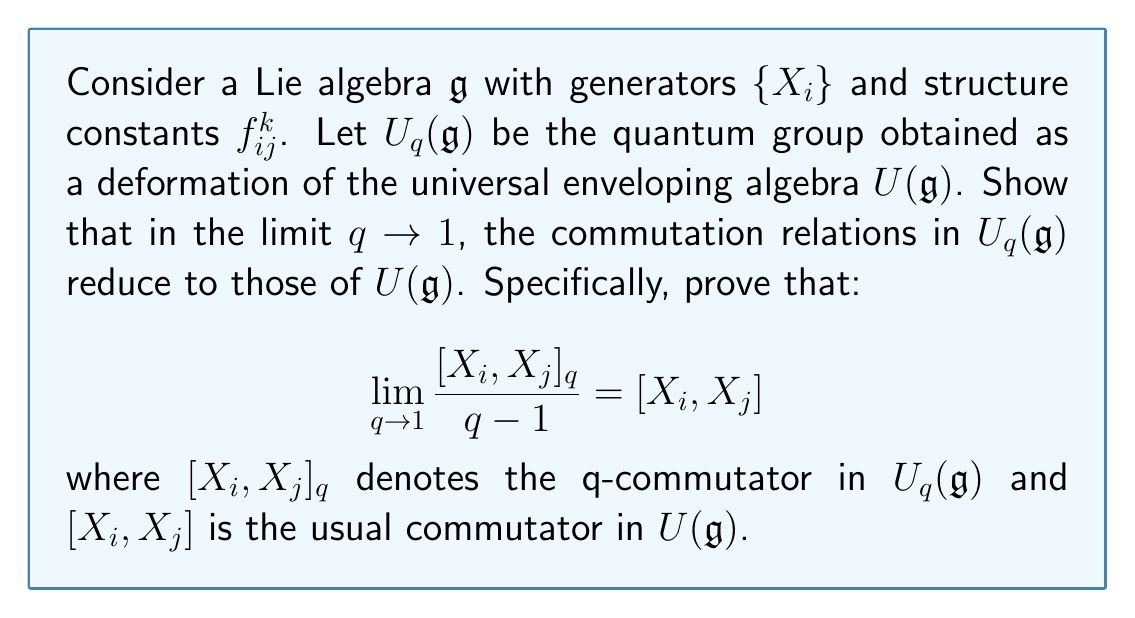Can you answer this question? To prove this statement, we'll follow these steps:

1) In the quantum group $U_q(\mathfrak{g})$, the q-commutator is defined as:

   $$[X_i, X_j]_q = q^{(X_i, X_j)} X_i X_j - q^{-(X_i, X_j)} X_j X_i$$

   where $(X_i, X_j)$ is the symmetrized Cartan matrix element.

2) We need to evaluate the limit:

   $$\lim_{q \to 1} \frac{[X_i, X_j]_q}{q-1}$$

3) Substituting the expression for the q-commutator:

   $$\lim_{q \to 1} \frac{q^{(X_i, X_j)} X_i X_j - q^{-(X_i, X_j)} X_j X_i}{q-1}$$

4) This limit has the form 0/0, so we can apply L'Hôpital's rule. Differentiating both numerator and denominator with respect to q:

   $$\lim_{q \to 1} \frac{(X_i, X_j)q^{(X_i, X_j)-1} X_i X_j + (X_i, X_j)q^{-(X_i, X_j)-1} X_j X_i}{1}$$

5) Now, taking the limit as $q \to 1$:

   $$(X_i, X_j) X_i X_j + (X_i, X_j) X_j X_i = (X_i, X_j)(X_i X_j - X_j X_i)$$

6) In the classical limit, the symmetrized Cartan matrix elements $(X_i, X_j)$ become the structure constants $f_{ij}^k$. Therefore:

   $$\lim_{q \to 1} \frac{[X_i, X_j]_q}{q-1} = f_{ij}^k (X_i X_j - X_j X_i) = [X_i, X_j]$$

This proves that in the limit $q \to 1$, the q-commutator in $U_q(\mathfrak{g})$ reduces to the standard commutator in $U(\mathfrak{g})$, demonstrating the relationship between quantum groups and deformations of universal enveloping algebras of Lie algebras.
Answer: $$\lim_{q \to 1} \frac{[X_i, X_j]_q}{q-1} = [X_i, X_j] = f_{ij}^k X_k$$ 